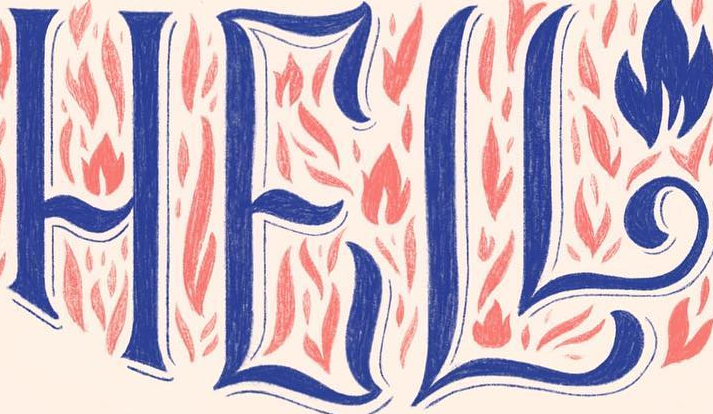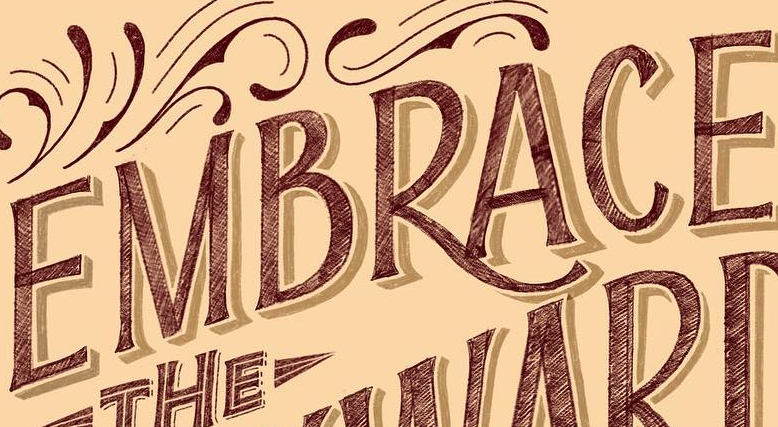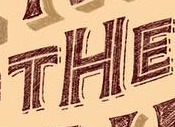Read the text content from these images in order, separated by a semicolon. HELL; EMBRACE; THE 